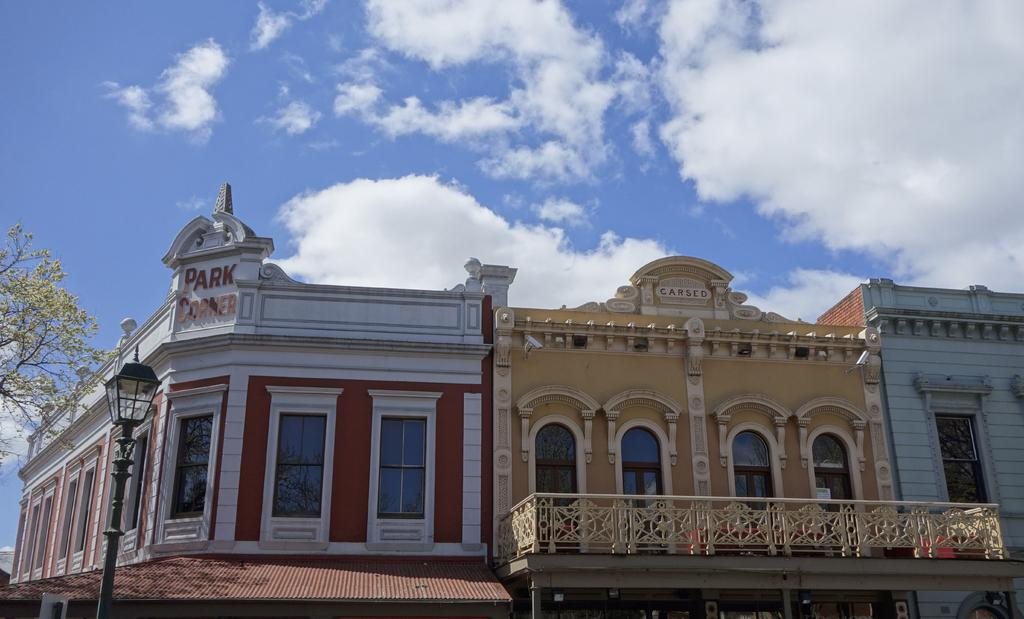What type of structures are present in the image? There are buildings in the image. What feature do the buildings have? The buildings have glass windows. What type of vegetation is present in the image? There are trees in the image. What colors can be seen in the sky in the image? The sky is blue and white in color. Can you tell me how many fans are visible in the image? There are no fans present in the image. What type of poison is being used by the dad in the image? There is no dad or poison present in the image. 